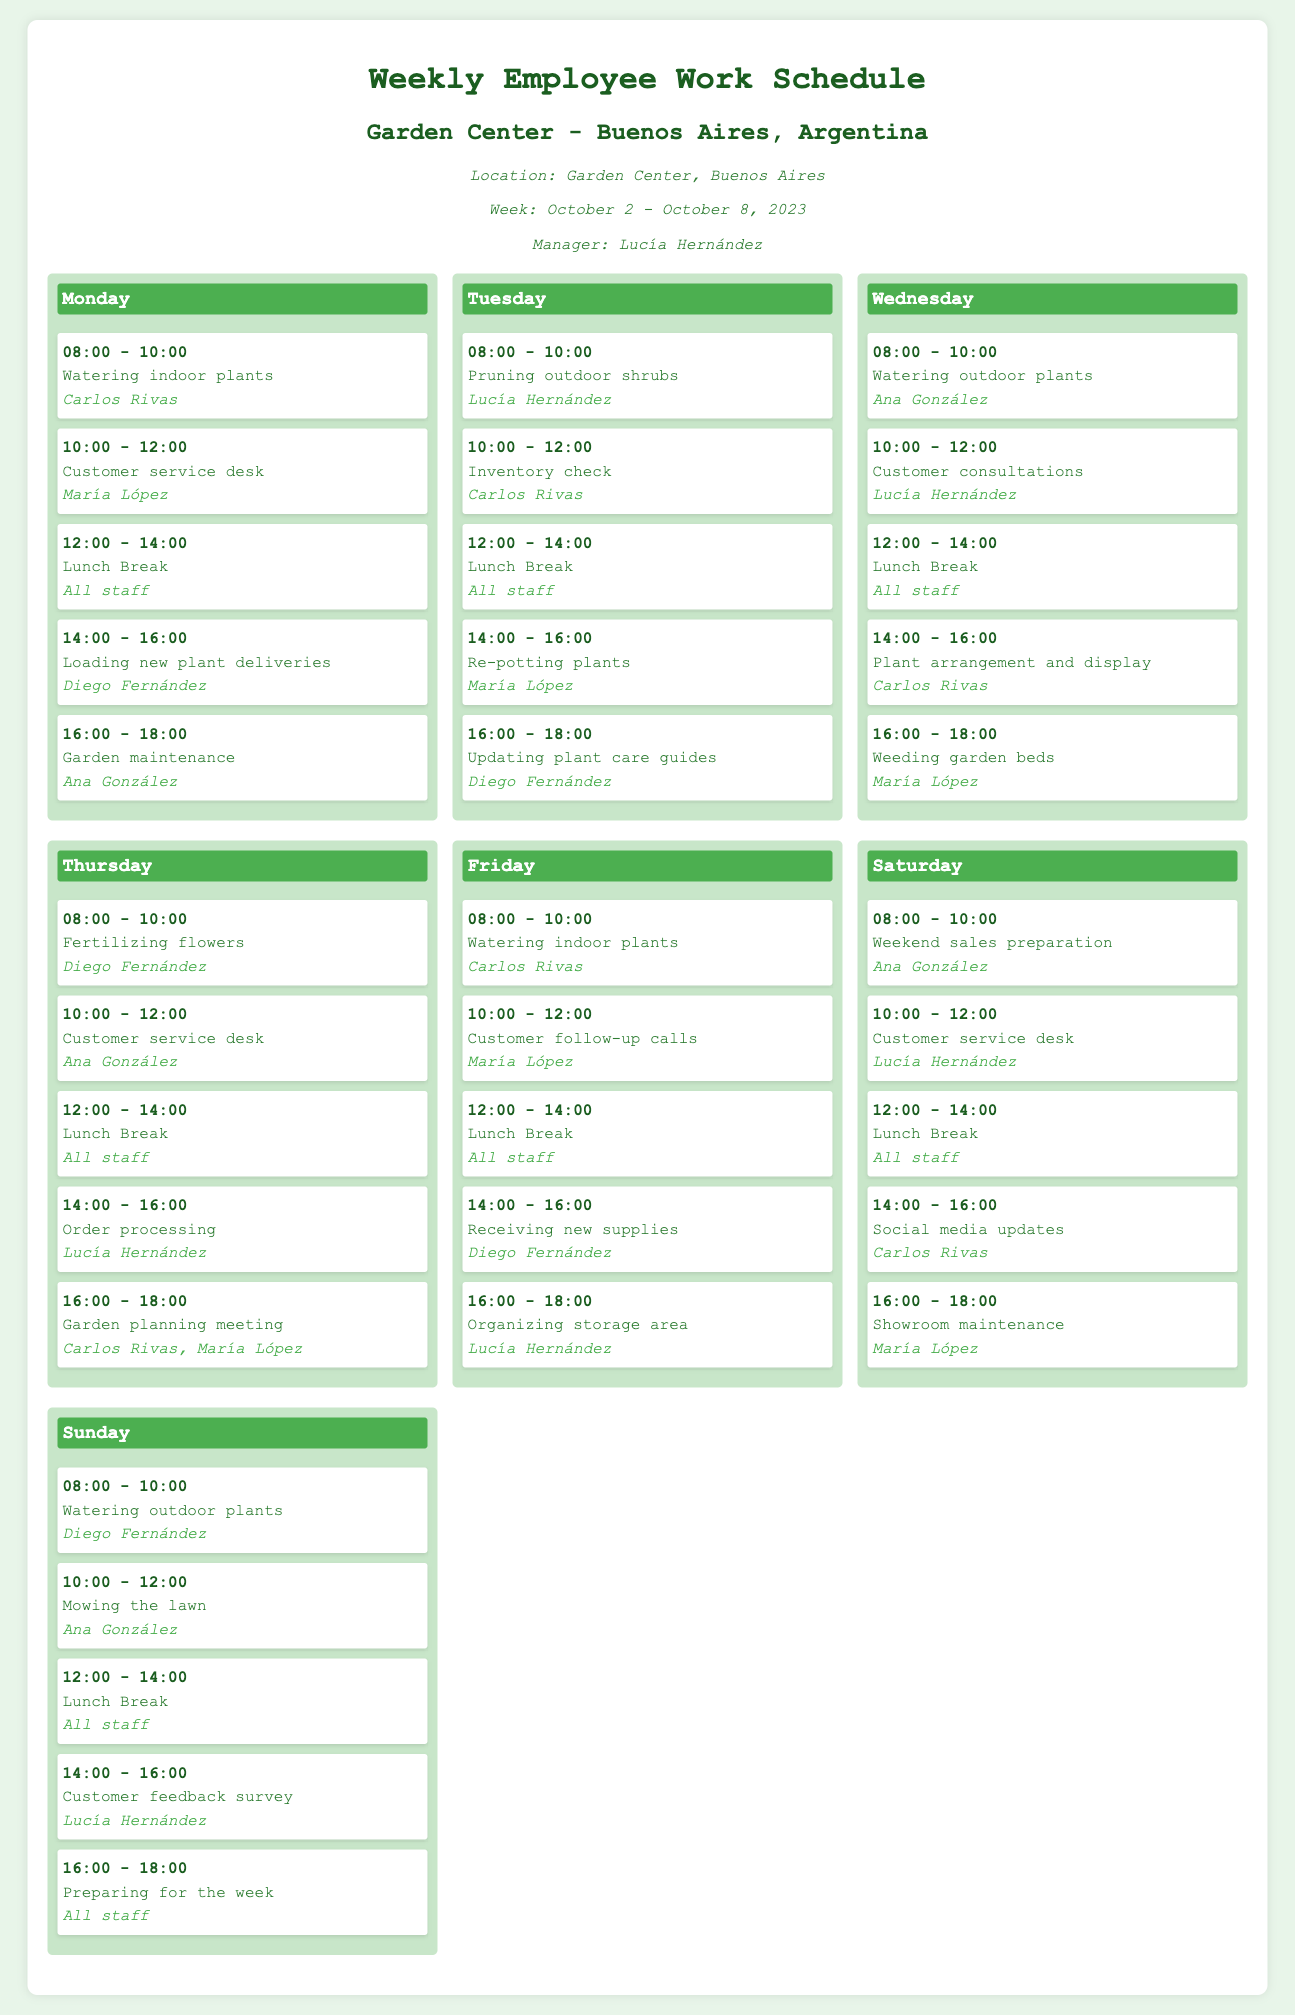What is the manager's name? The manager's name is specified at the top of the document in the meta information section.
Answer: Lucía Hernández Which employee is assigned to watering indoor plants on Friday? The task section for Friday lists the employee responsible for watering indoor plants.
Answer: Carlos Rivas How many hours are allocated for the lunch break each day? The lunch break duration is consistent across all days, as indicated in the document.
Answer: 2 hours What task is scheduled from 14:00 to 16:00 on Thursday? The Thursday tasks section outlines what is scheduled during that time slot.
Answer: Order processing On which day does Ana González conduct customer consultations? The schedule for Wednesday states who is assigned to conduct customer consultations.
Answer: Wednesday Who is watering outdoor plants on Sunday? The task for Sunday highlights the employee responsible for watering outdoor plants.
Answer: Diego Fernández What time does the Saturday shift start? The schedule details the start time of the Saturday shift, as listed in the document.
Answer: 08:00 Which two employees are involved in the garden planning meeting on Thursday? The Thursday tasks provide information about who is attending the garden planning meeting.
Answer: Carlos Rivas, María López What is the total number of employees working at the garden center during the week? The employee names listed throughout the schedule show how many unique employees will work that week.
Answer: 5 